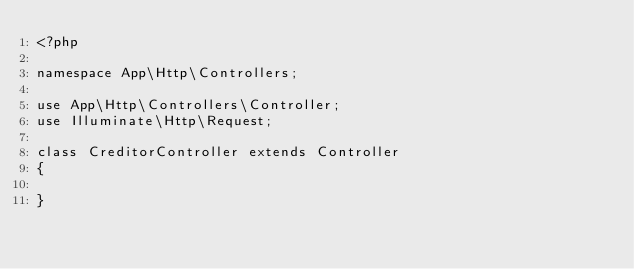<code> <loc_0><loc_0><loc_500><loc_500><_PHP_><?php

namespace App\Http\Controllers;

use App\Http\Controllers\Controller;
use Illuminate\Http\Request;

class CreditorController extends Controller
{
    
}
</code> 